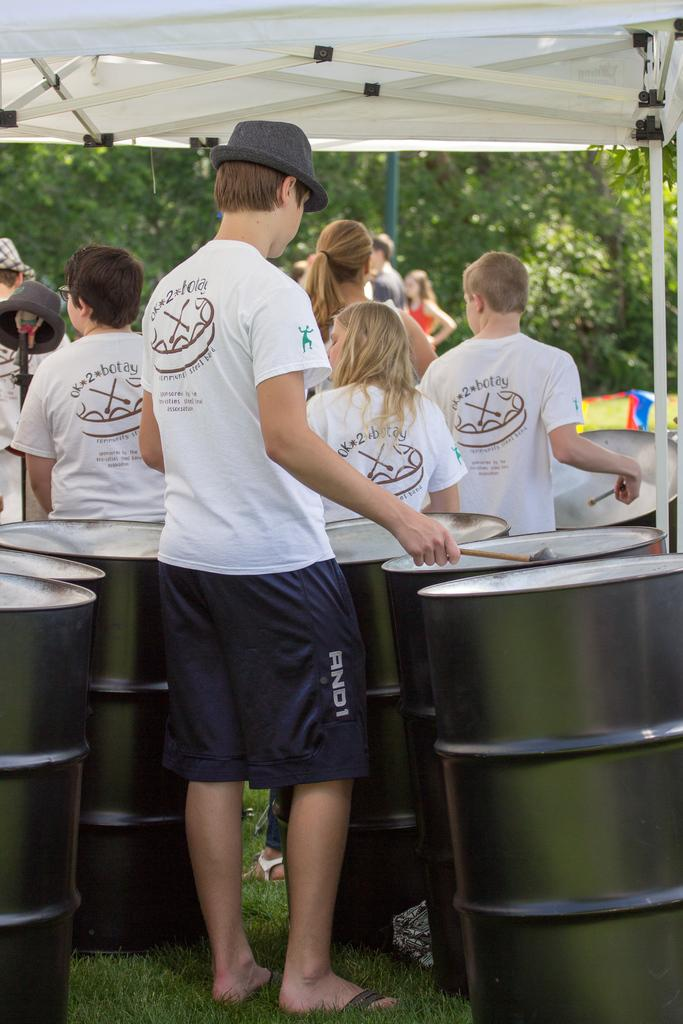<image>
Share a concise interpretation of the image provided. a man with And 1 shorts on with other people outdoors 